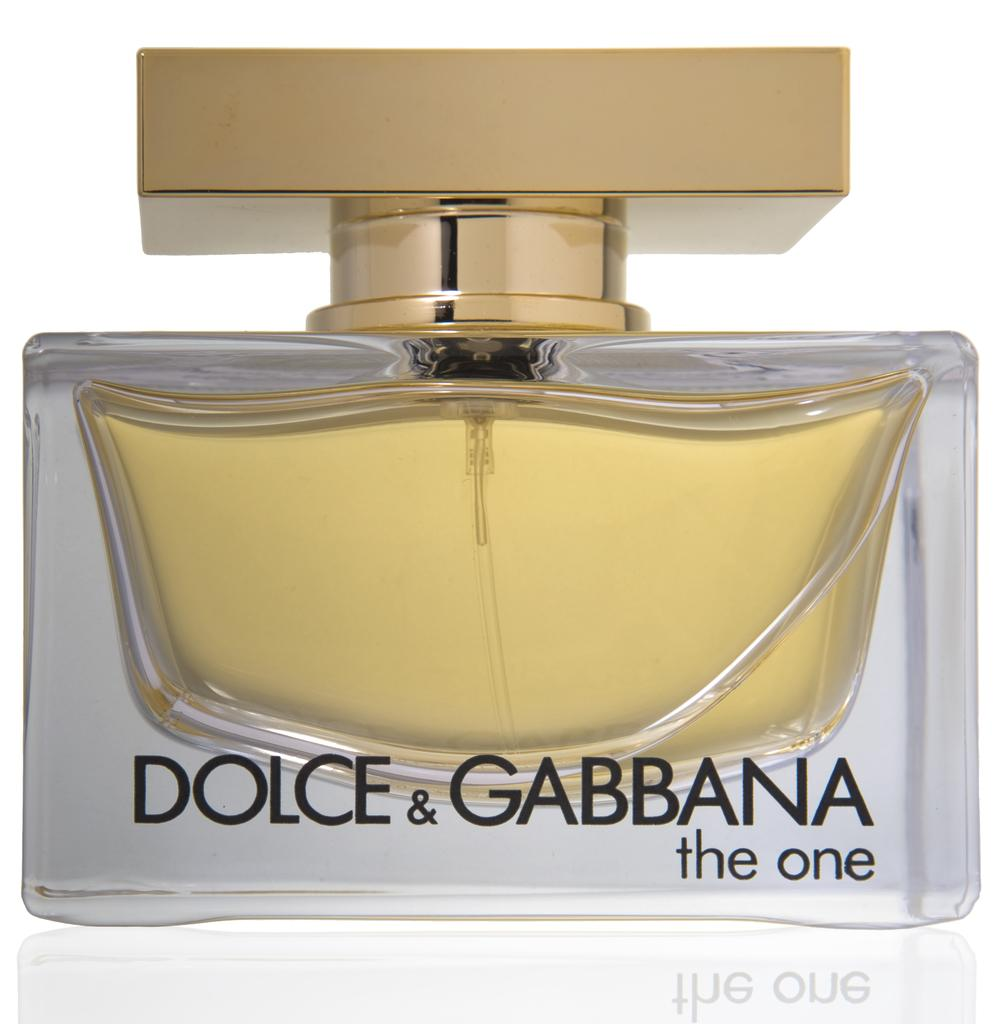<image>
Write a terse but informative summary of the picture. The One by Dolce & Gabbana comes in a glass bottle with a gold-toned cap. 